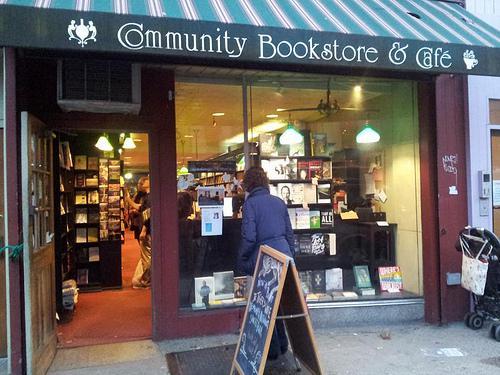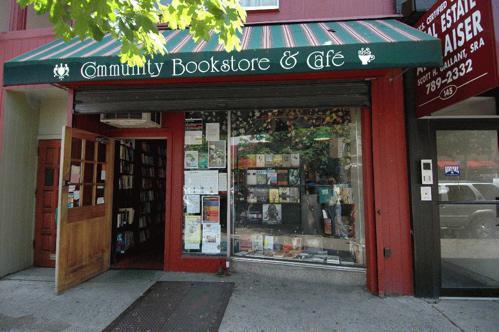The first image is the image on the left, the second image is the image on the right. Evaluate the accuracy of this statement regarding the images: "wooden french doors are open and visible from the inside of the store". Is it true? Answer yes or no. No. The first image is the image on the left, the second image is the image on the right. Examine the images to the left and right. Is the description "There is a stained glass window visible over the doorway." accurate? Answer yes or no. No. 